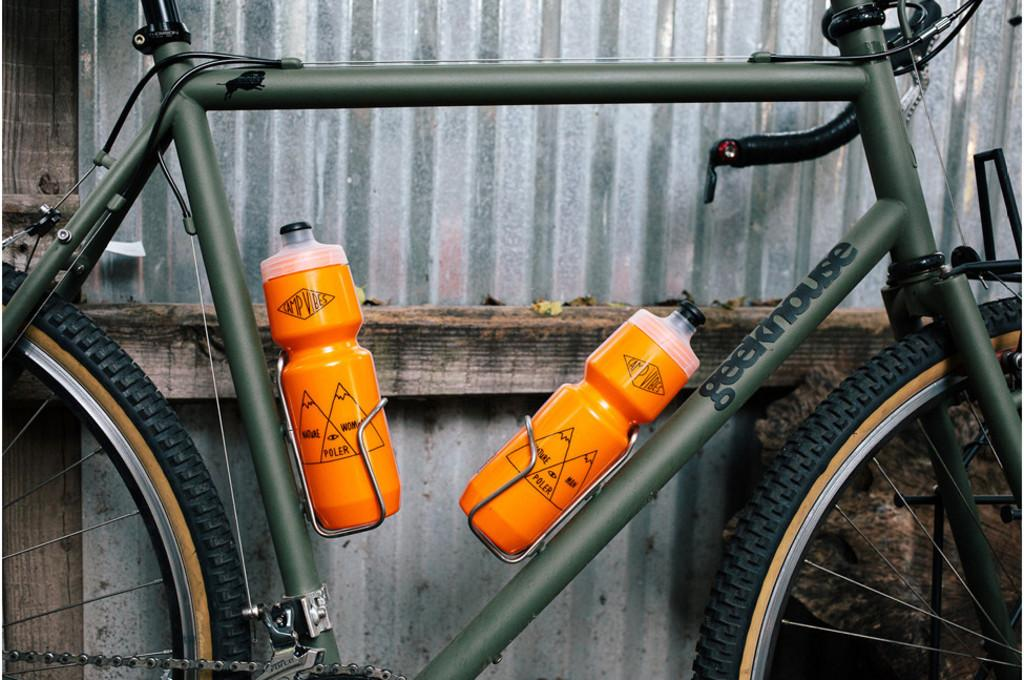What is the main object in the image? There is a bicycle in the image. Are there any accessories attached to the bicycle? Yes, the bicycle has two water bottles. What can be seen in the background of the image? There is a roof visible in the background of the image. What type of toy can be seen on the bicycle in the image? There is no toy present on the bicycle in the image. Can you hear the horn of the bicycle in the image? There is no horn present on the bicycle in the image, so it cannot be heard. 